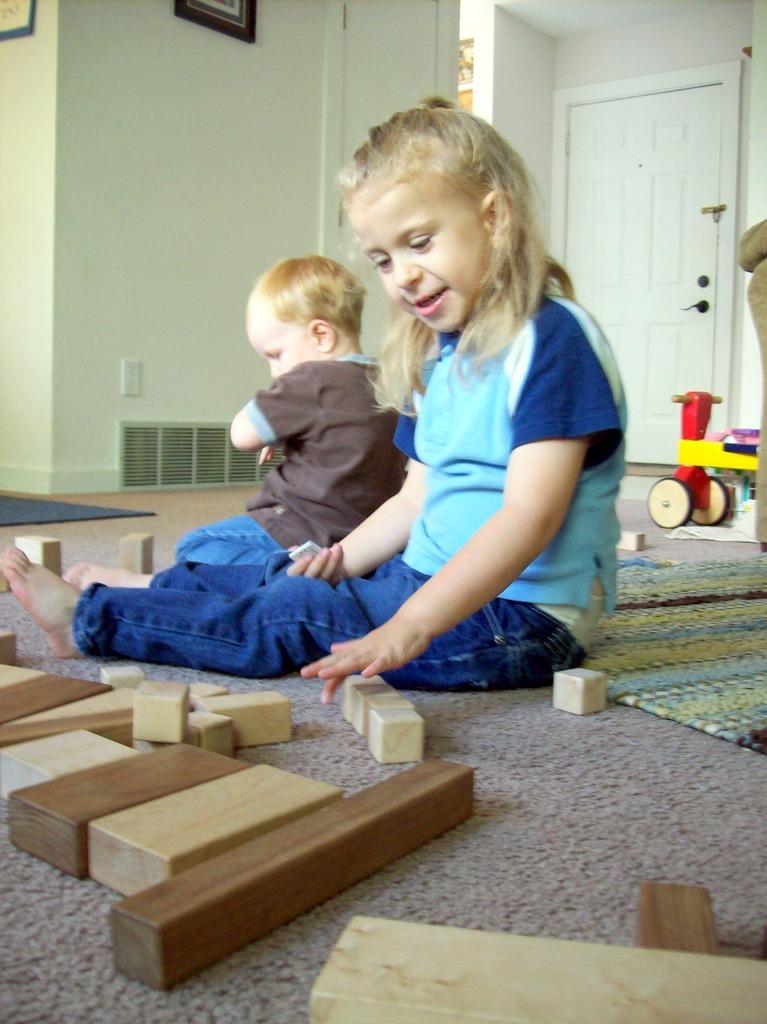How many kids are present in the image? There are two kids in the image. What are the kids doing in the image? The kids are seated on the floor. What objects are in front of the kids? There are blocks in front of the kids. What can be seen on the wall in the background of the image? There are frames on the wall in the background of the image. What type of flesh can be seen in the image? There is no flesh visible in the image; it features two kids seated on the floor with blocks in front of them. 